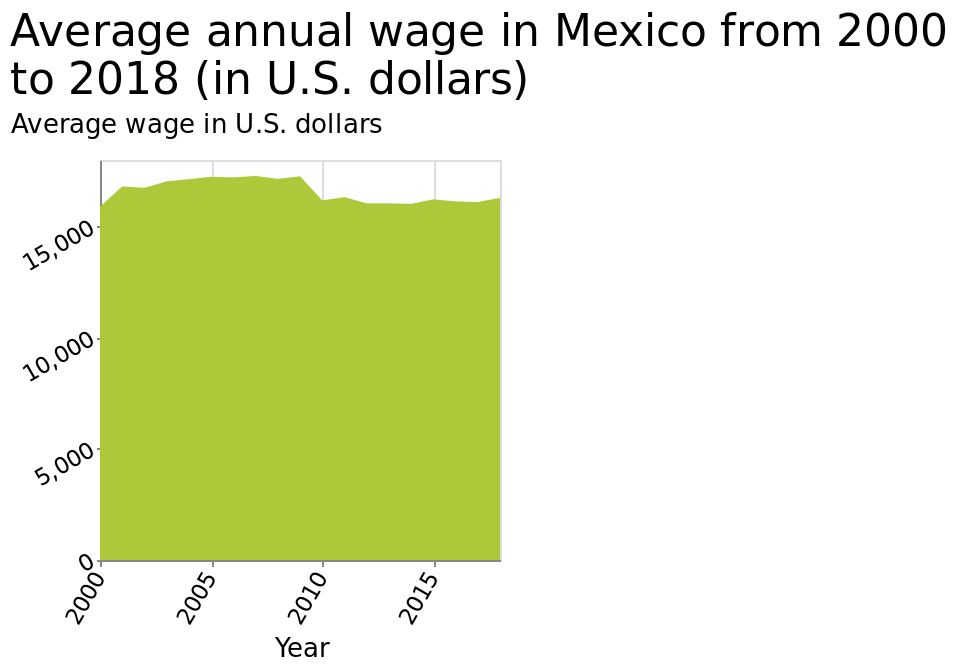<image>
What is the range for the average wage in U.S. dollars on the y-axis? The range for the average wage in U.S. dollars on the y-axis is from 0 to 15,000. How is the average wage in U.S. dollars measured? The average wage in U.S. dollars is measured using a linear scale with a minimum of 0 and a maximum of 15,000 along the y-axis. 